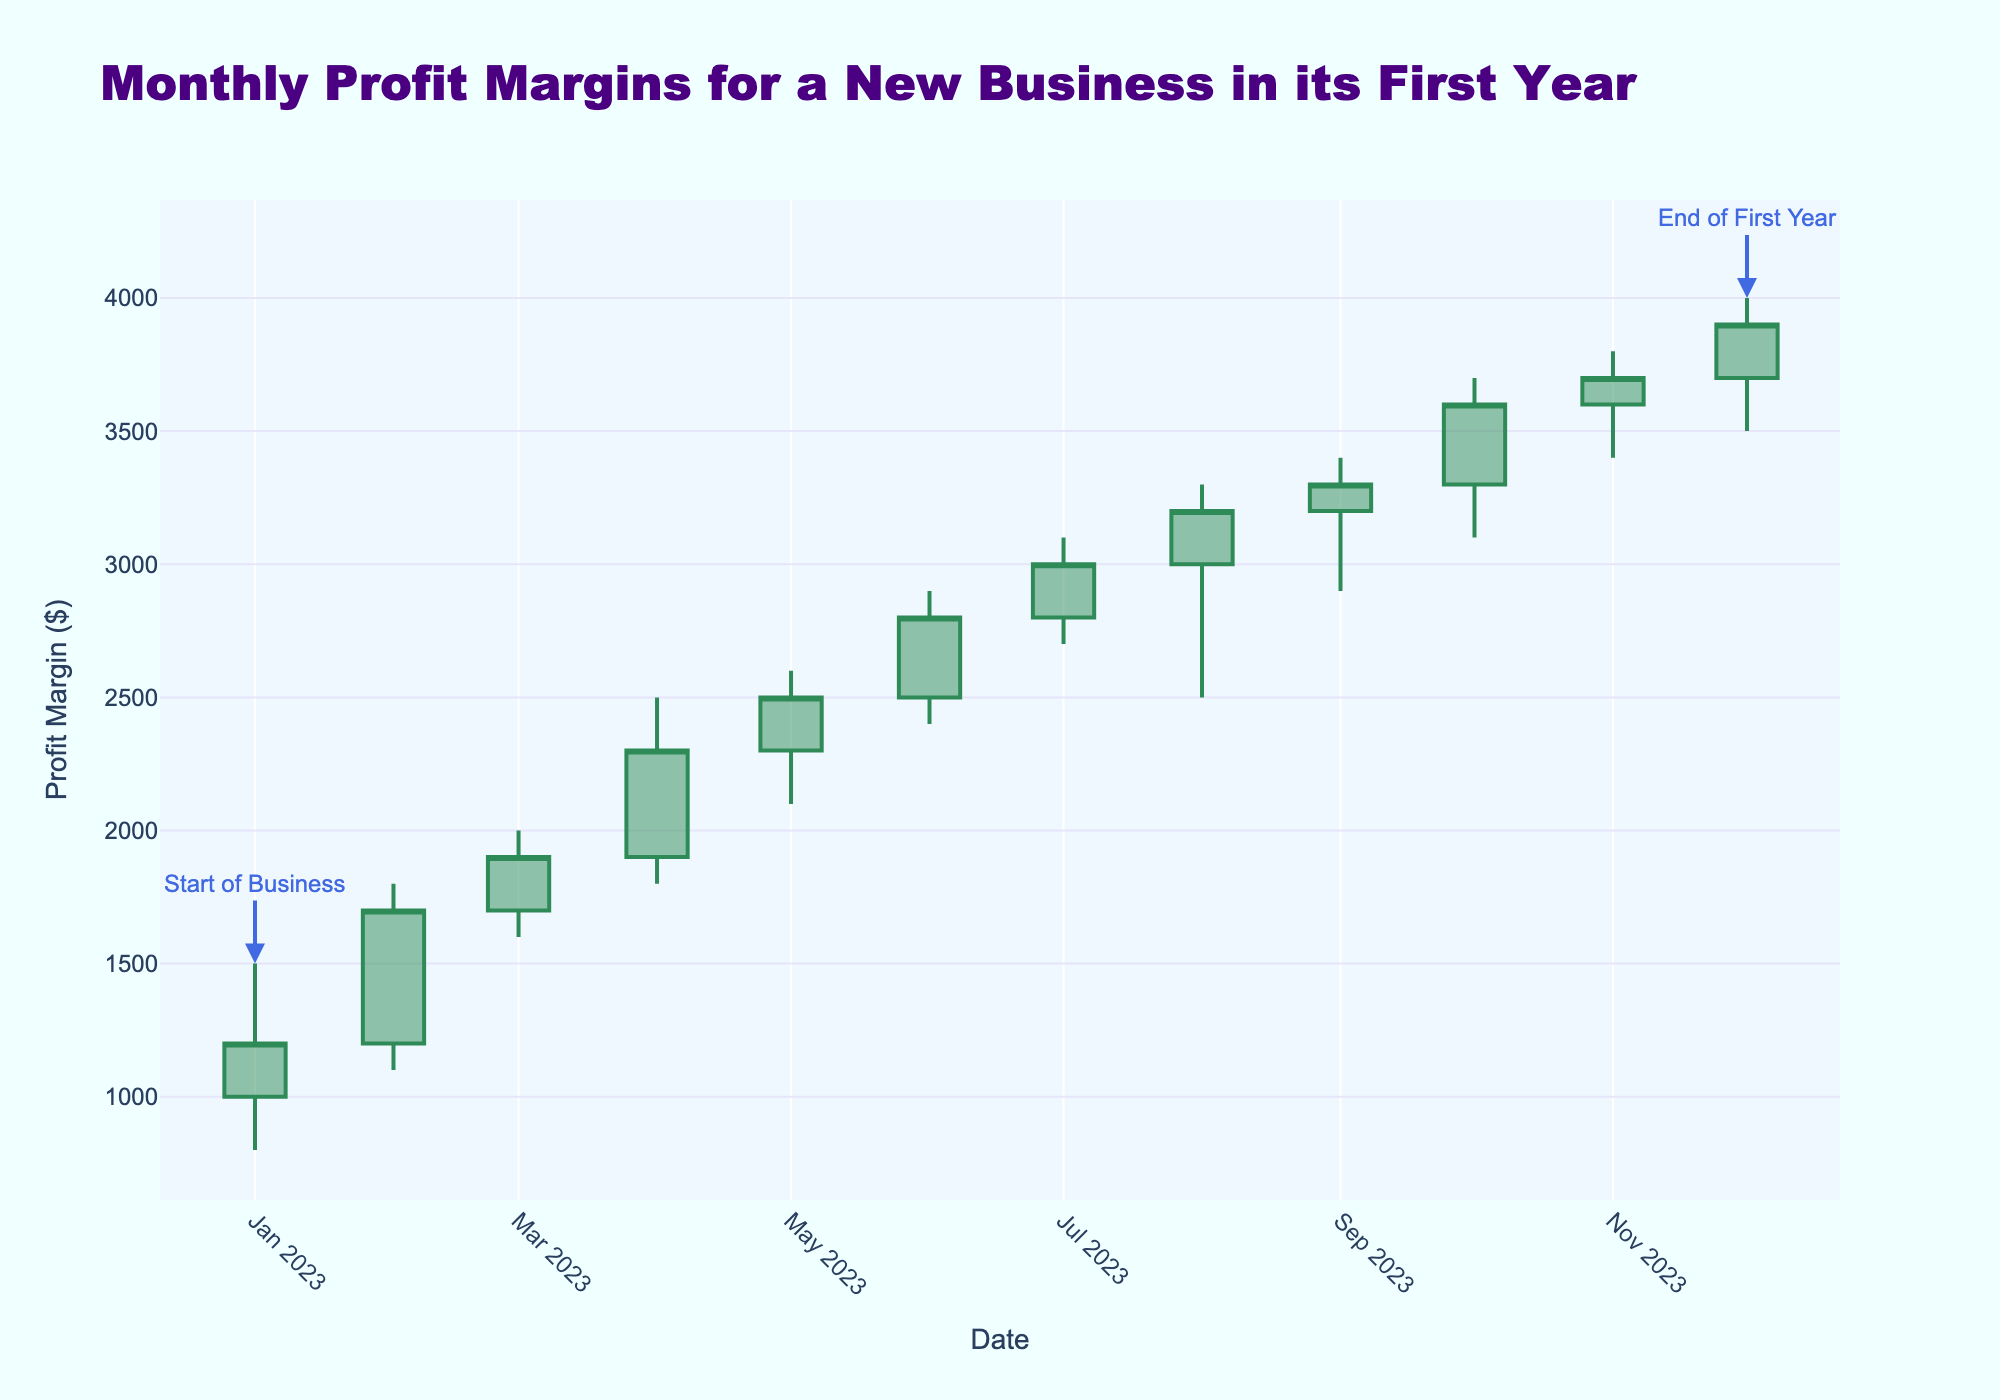What is the title of the chart? The title of the chart is displayed at the top of the figure.
Answer: Monthly Profit Margins for a New Business in its First Year What is the profit margin at the end of the first year? The profit margin at the end of the first year corresponds to the "Close" value for December 2023.
Answer: $3900 How many months show profit margins increasing (closing higher than opening)? Examine each month's candlestick and check if the "Close" value is higher than the "Open" value. If so, count it as an increase.
Answer: 11 Which month had the highest high value and what was it? Look for the month with the tallest upper wick on the candlesticks, which indicates the highest high value.
Answer: December 2023, $4000 Which month had the most significant drop from high to low? Calculate the difference between the "High" and "Low" values for each month, and identify the month with the largest difference.
Answer: August 2023, $800 What was the trend in profit margins over the last quarter of the year? Analyze the "Close" values for October, November, and December to determine if they are generally increasing, decreasing, or stable.
Answer: Increasing In which month did the profit margins start to consistently close higher than 2000? Identify the first month where the "Close" value is higher than 2000 and remains so for the subsequent months.
Answer: June 2023 What is the average "Open" value for the first six months? Sum the "Open" values for January to June and divide by 6 to find the average.
Answer: $1783.33 Compare the high and low values of July and August. Which month had more volatility? Examine the difference between "High" and "Low" values for July and August, then compare them to determine which month had greater volatility.
Answer: August 2023 What is the closing profit margin in October and how does it compare to the opening profit margin in November? Look at the "Close" value for October and the "Open" value for November, and compare them to see which is higher.
Answer: October Close: $3600, November Open: $3600, Same 